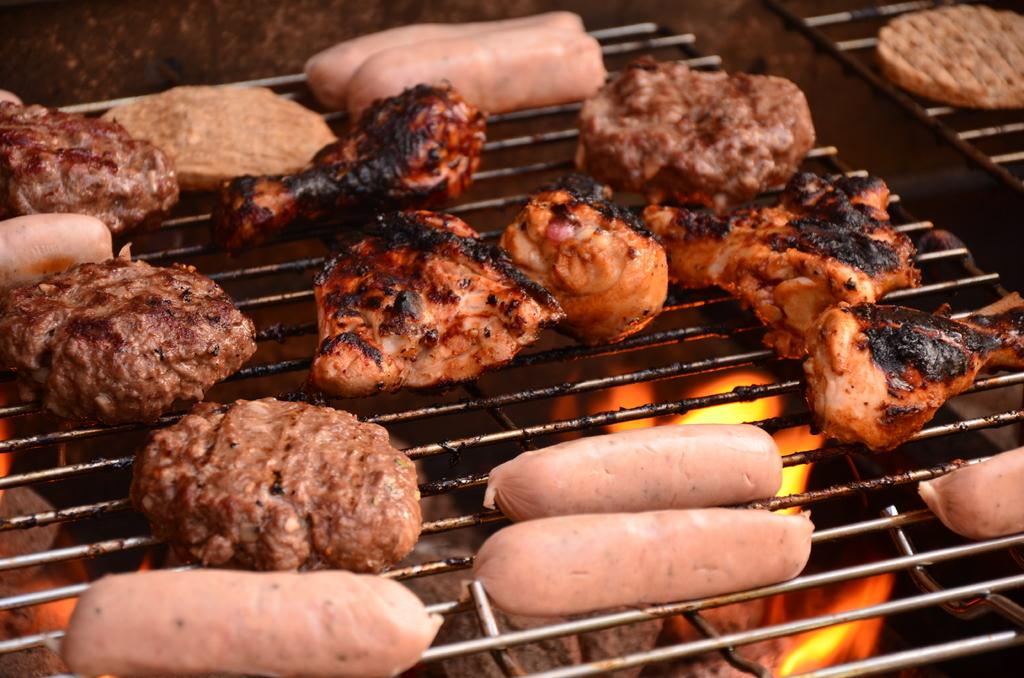What type of food is being cooked on the grill pan? There are sausages and pieces of meat on the grill pan. How is the grill pan being used? The grill pan is positioned over fire to cook the food. What type of bird can be seen perched on the edge of the grill pan? There is no bird present on the edge of the grill pan in the image. 